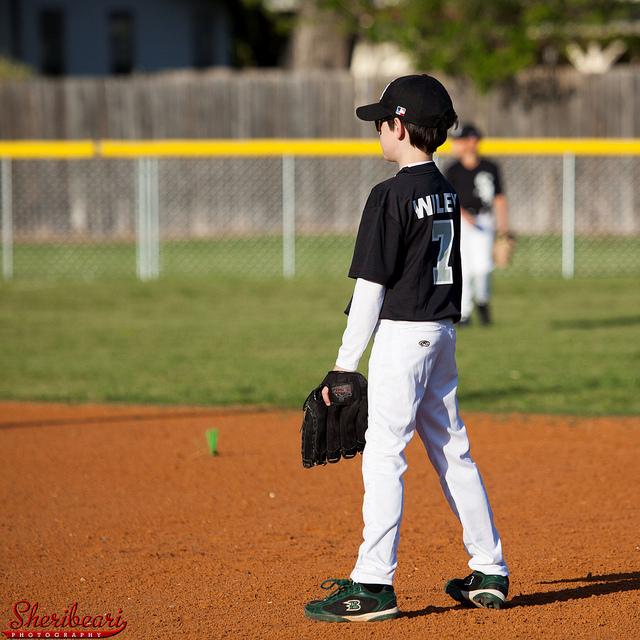What color is his hat?
Be succinct. Black. Why does it say number 7 on the boy's shirt?
Concise answer only. Personal upgrade. How many different teams are represented in this picture?
Answer briefly. 1. What are the teams color?
Concise answer only. Black and white. What is the name on the Jersey the kids are wearing?
Concise answer only. Wiley. What game is being played?
Keep it brief. Baseball. Is the boy wearing a glove?
Write a very short answer. Yes. 